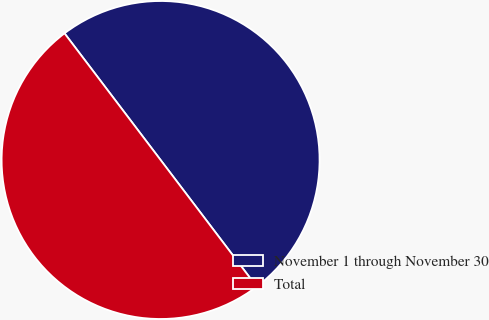Convert chart to OTSL. <chart><loc_0><loc_0><loc_500><loc_500><pie_chart><fcel>November 1 through November 30<fcel>Total<nl><fcel>50.0%<fcel>50.0%<nl></chart> 